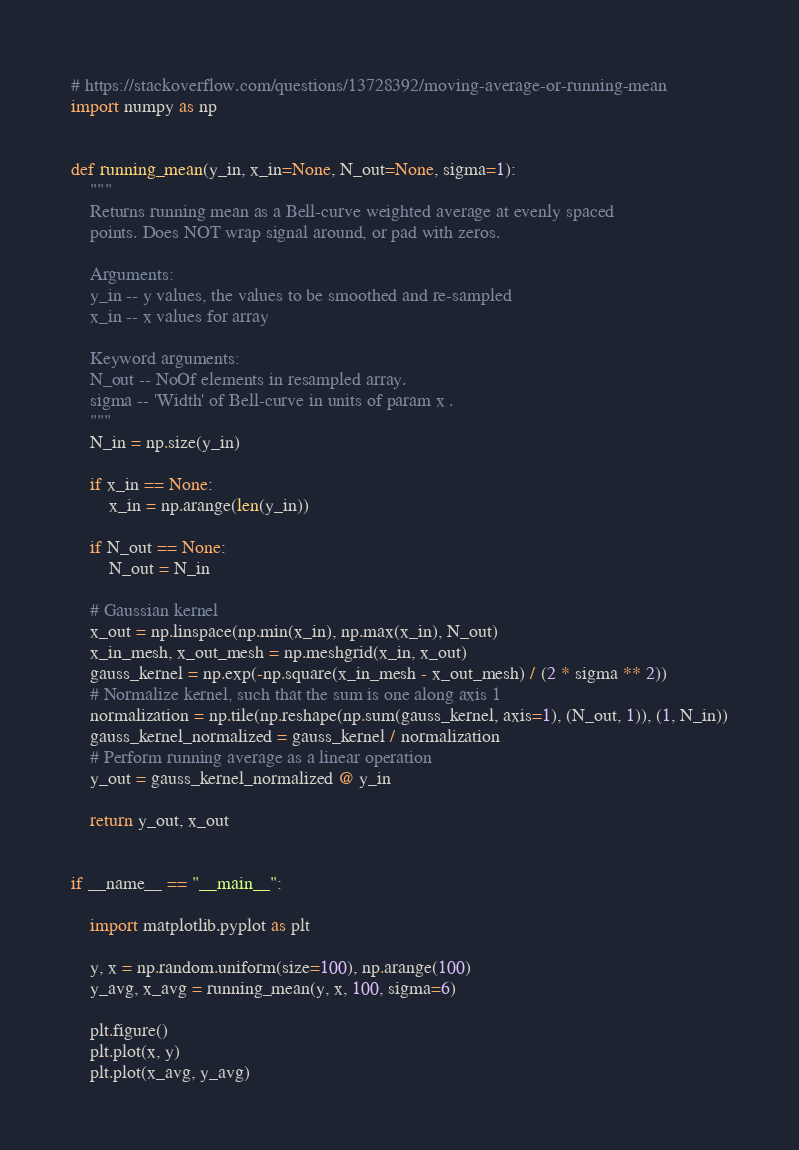Convert code to text. <code><loc_0><loc_0><loc_500><loc_500><_Python_># https://stackoverflow.com/questions/13728392/moving-average-or-running-mean
import numpy as np


def running_mean(y_in, x_in=None, N_out=None, sigma=1):
    """
    Returns running mean as a Bell-curve weighted average at evenly spaced
    points. Does NOT wrap signal around, or pad with zeros.

    Arguments:
    y_in -- y values, the values to be smoothed and re-sampled
    x_in -- x values for array

    Keyword arguments:
    N_out -- NoOf elements in resampled array.
    sigma -- 'Width' of Bell-curve in units of param x .
    """
    N_in = np.size(y_in)

    if x_in == None:
        x_in = np.arange(len(y_in))

    if N_out == None:
        N_out = N_in

    # Gaussian kernel
    x_out = np.linspace(np.min(x_in), np.max(x_in), N_out)
    x_in_mesh, x_out_mesh = np.meshgrid(x_in, x_out)
    gauss_kernel = np.exp(-np.square(x_in_mesh - x_out_mesh) / (2 * sigma ** 2))
    # Normalize kernel, such that the sum is one along axis 1
    normalization = np.tile(np.reshape(np.sum(gauss_kernel, axis=1), (N_out, 1)), (1, N_in))
    gauss_kernel_normalized = gauss_kernel / normalization
    # Perform running average as a linear operation
    y_out = gauss_kernel_normalized @ y_in

    return y_out, x_out


if __name__ == "__main__":

    import matplotlib.pyplot as plt

    y, x = np.random.uniform(size=100), np.arange(100)
    y_avg, x_avg = running_mean(y, x, 100, sigma=6)

    plt.figure()
    plt.plot(x, y)
    plt.plot(x_avg, y_avg)
</code> 